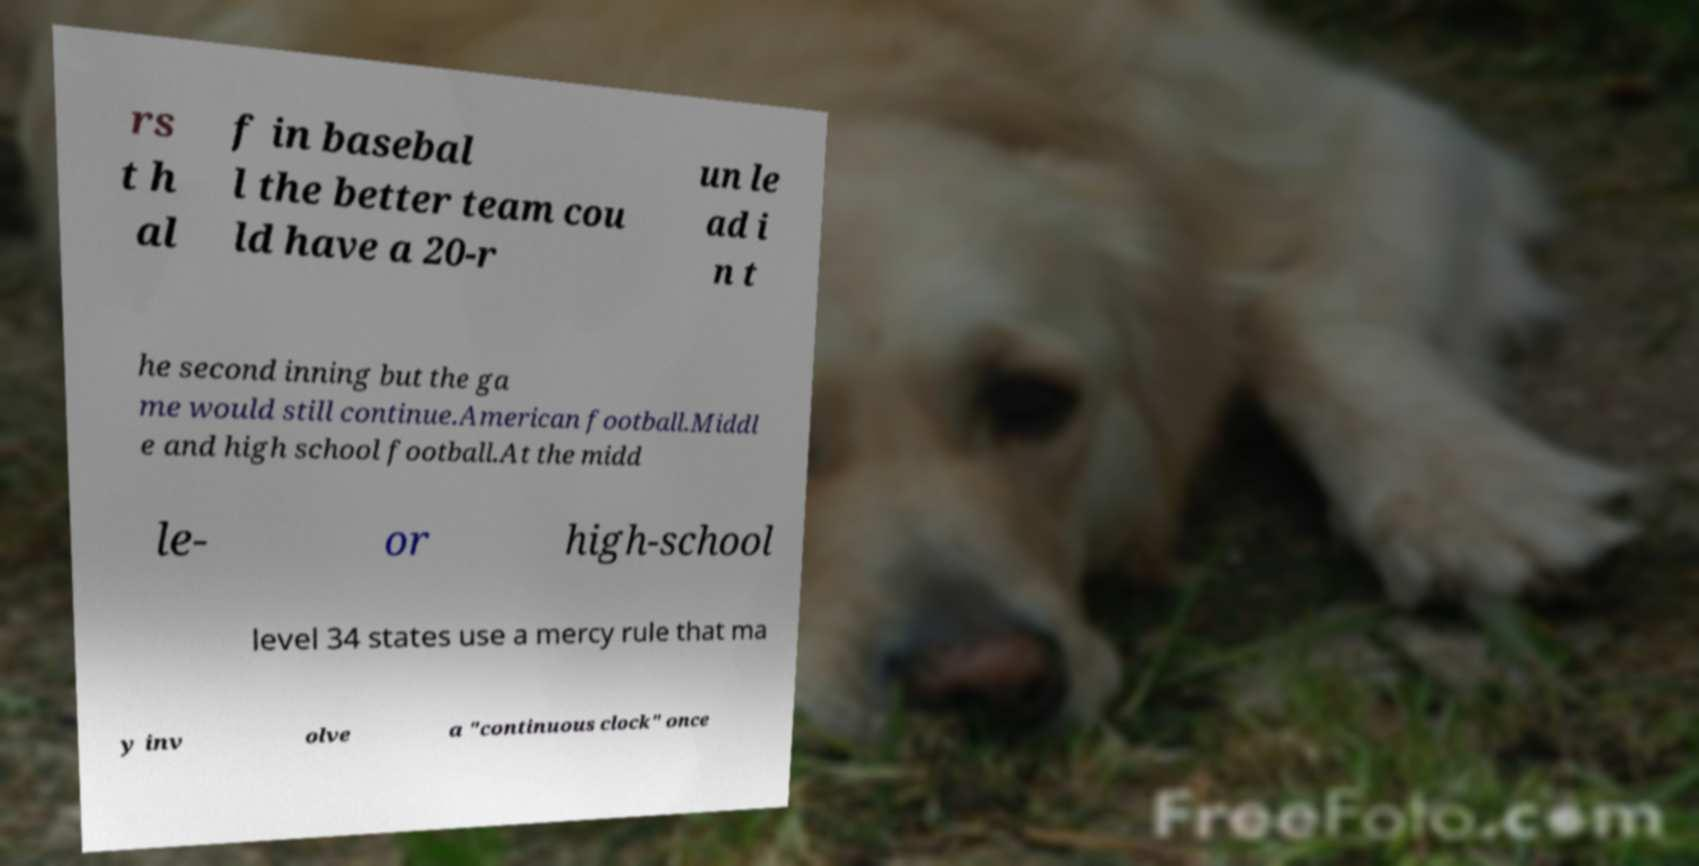For documentation purposes, I need the text within this image transcribed. Could you provide that? rs t h al f in basebal l the better team cou ld have a 20-r un le ad i n t he second inning but the ga me would still continue.American football.Middl e and high school football.At the midd le- or high-school level 34 states use a mercy rule that ma y inv olve a "continuous clock" once 